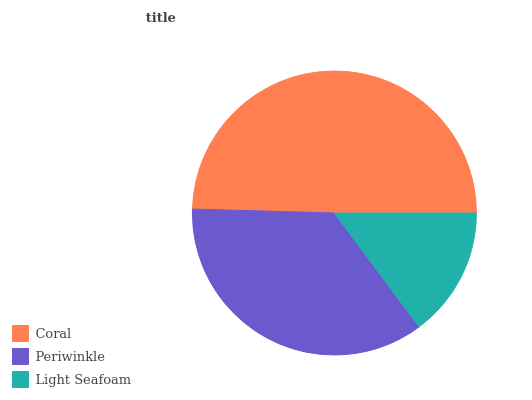Is Light Seafoam the minimum?
Answer yes or no. Yes. Is Coral the maximum?
Answer yes or no. Yes. Is Periwinkle the minimum?
Answer yes or no. No. Is Periwinkle the maximum?
Answer yes or no. No. Is Coral greater than Periwinkle?
Answer yes or no. Yes. Is Periwinkle less than Coral?
Answer yes or no. Yes. Is Periwinkle greater than Coral?
Answer yes or no. No. Is Coral less than Periwinkle?
Answer yes or no. No. Is Periwinkle the high median?
Answer yes or no. Yes. Is Periwinkle the low median?
Answer yes or no. Yes. Is Coral the high median?
Answer yes or no. No. Is Coral the low median?
Answer yes or no. No. 